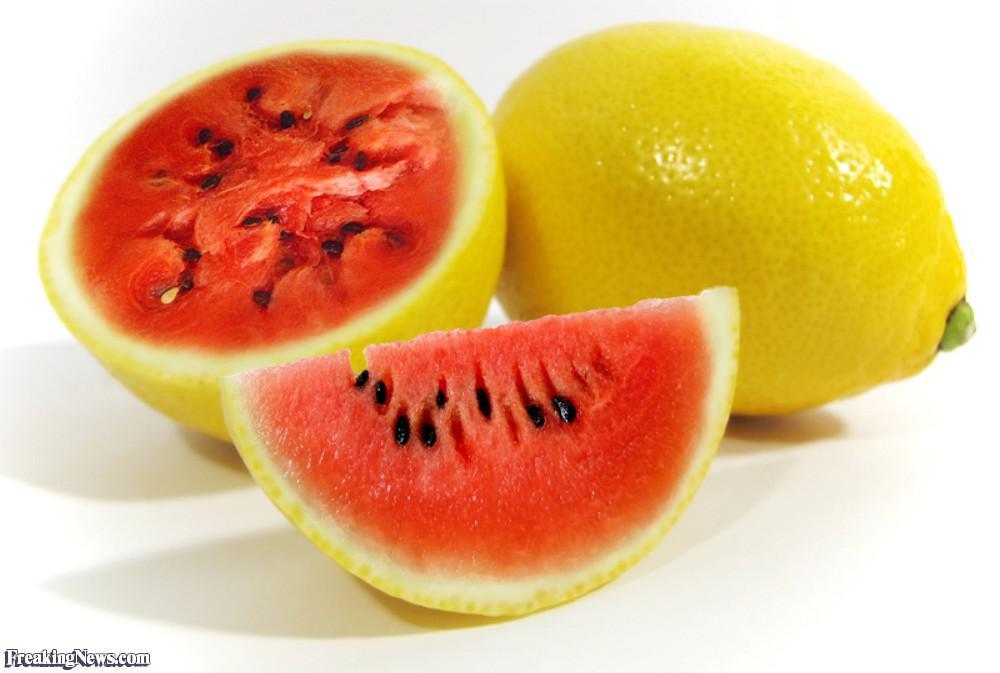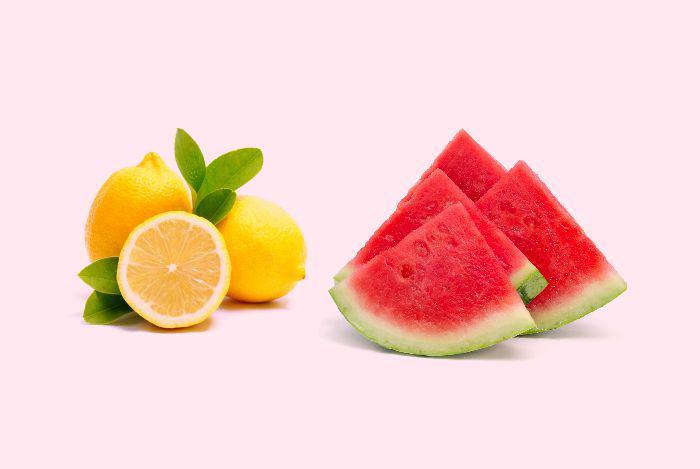The first image is the image on the left, the second image is the image on the right. For the images displayed, is the sentence "At least one small pink drink with a garnish of lemon or watermelon is seen in each image." factually correct? Answer yes or no. No. 